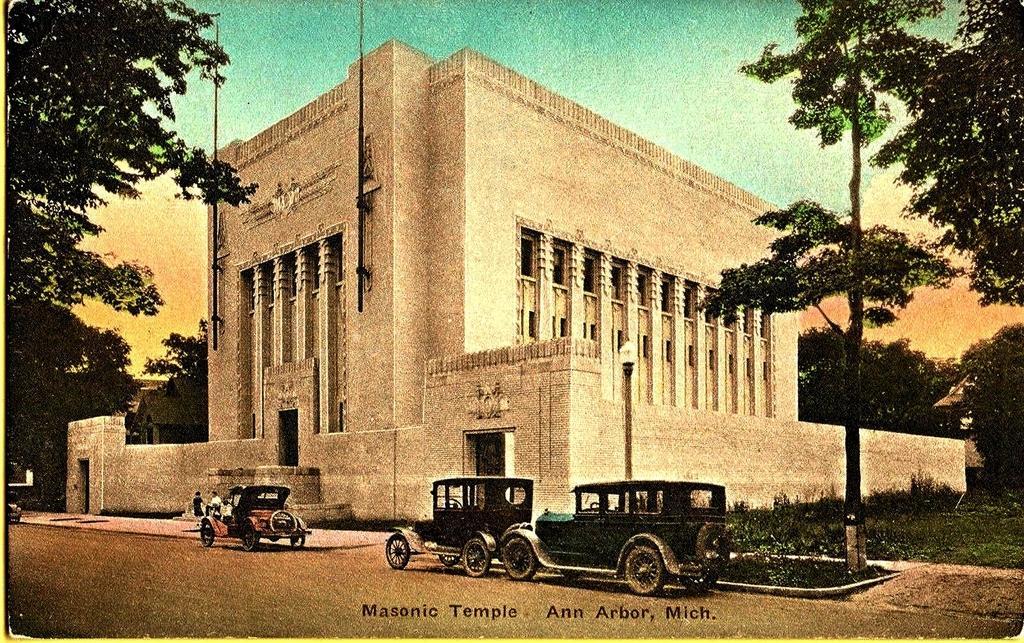In one or two sentences, can you explain what this image depicts? It is an old image,there is a big fort and in front of the fort there are three vehicles and in front of the first vehicle there are two people standing and around the fort there are plenty of trees. 